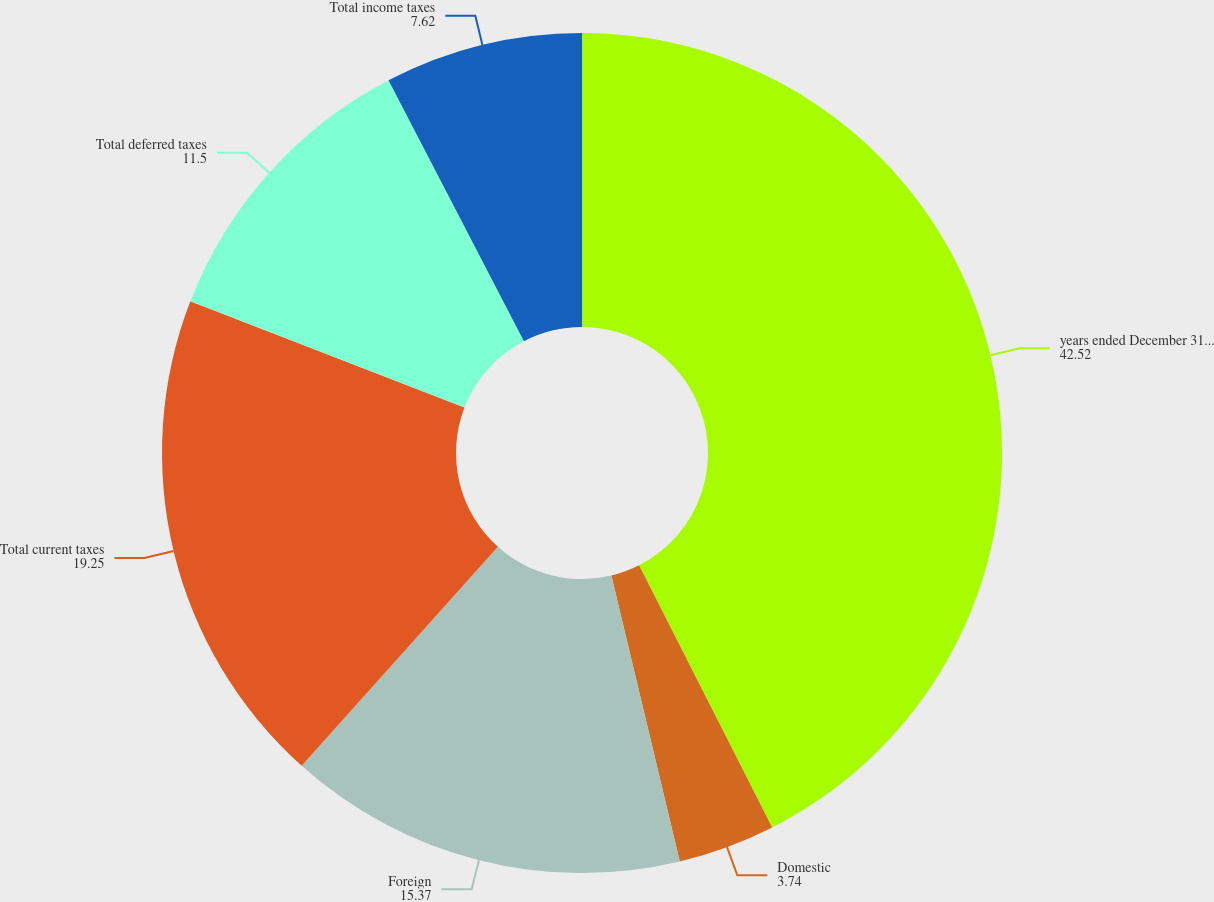Convert chart to OTSL. <chart><loc_0><loc_0><loc_500><loc_500><pie_chart><fcel>years ended December 31 (in<fcel>Domestic<fcel>Foreign<fcel>Total current taxes<fcel>Total deferred taxes<fcel>Total income taxes<nl><fcel>42.52%<fcel>3.74%<fcel>15.37%<fcel>19.25%<fcel>11.5%<fcel>7.62%<nl></chart> 